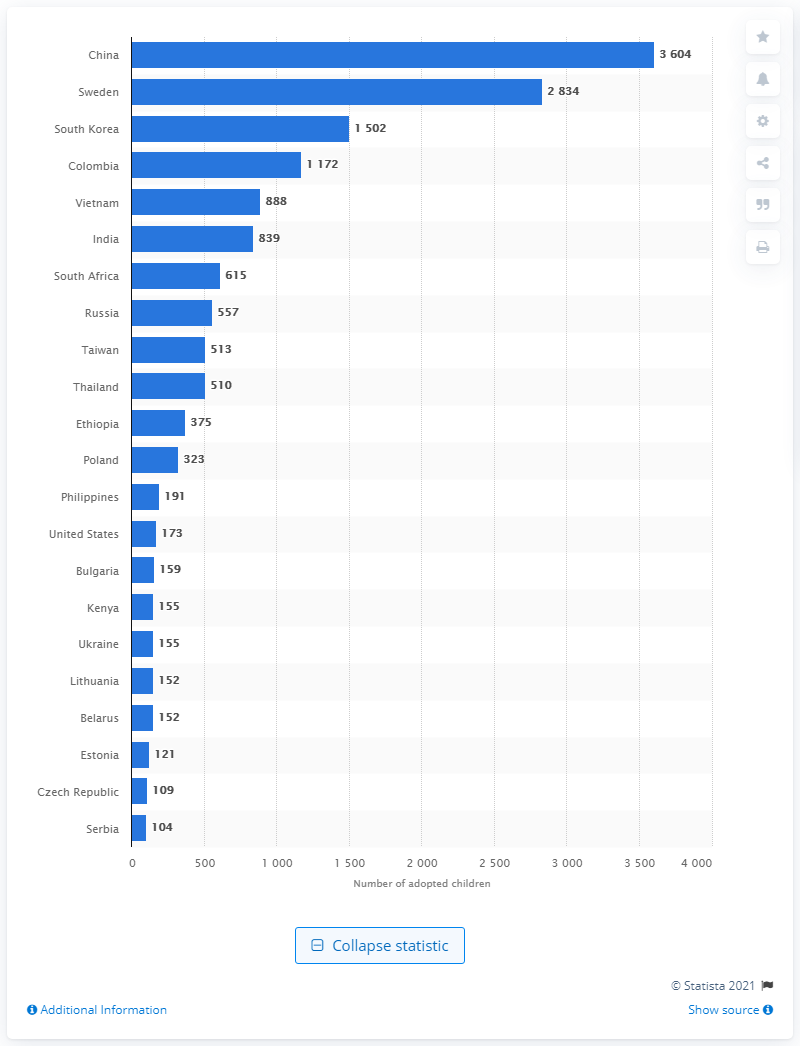List a handful of essential elements in this visual. South Korea had the highest number of adopted children among all countries. 